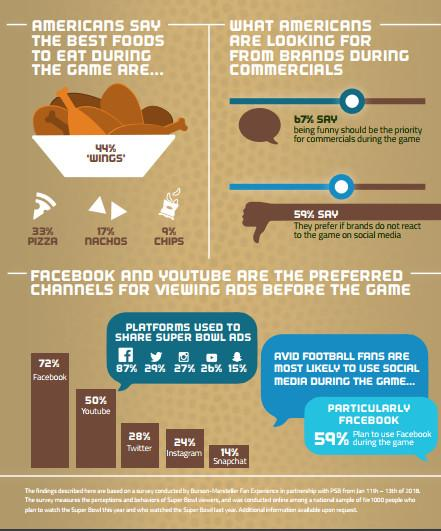Highlight a few significant elements in this photo. According to a survey, 33% of Americans prefer pizza to eat while watching the game. According to the given data, 24% of the people prefer Instagram for viewing ads before the game. Eighty-seven percent of Super Bowl ads are shared on Facebook. 